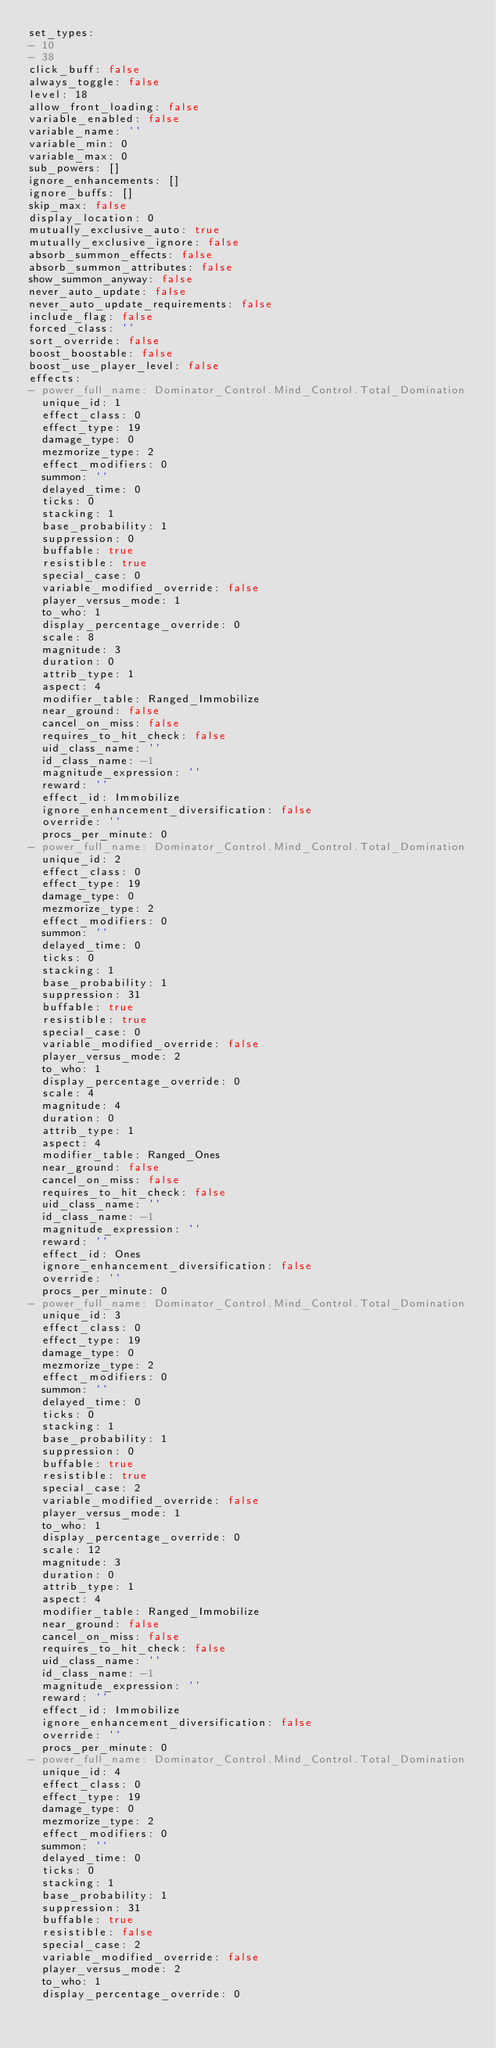Convert code to text. <code><loc_0><loc_0><loc_500><loc_500><_YAML_>set_types:
- 10
- 38
click_buff: false
always_toggle: false
level: 18
allow_front_loading: false
variable_enabled: false
variable_name: ''
variable_min: 0
variable_max: 0
sub_powers: []
ignore_enhancements: []
ignore_buffs: []
skip_max: false
display_location: 0
mutually_exclusive_auto: true
mutually_exclusive_ignore: false
absorb_summon_effects: false
absorb_summon_attributes: false
show_summon_anyway: false
never_auto_update: false
never_auto_update_requirements: false
include_flag: false
forced_class: ''
sort_override: false
boost_boostable: false
boost_use_player_level: false
effects:
- power_full_name: Dominator_Control.Mind_Control.Total_Domination
  unique_id: 1
  effect_class: 0
  effect_type: 19
  damage_type: 0
  mezmorize_type: 2
  effect_modifiers: 0
  summon: ''
  delayed_time: 0
  ticks: 0
  stacking: 1
  base_probability: 1
  suppression: 0
  buffable: true
  resistible: true
  special_case: 0
  variable_modified_override: false
  player_versus_mode: 1
  to_who: 1
  display_percentage_override: 0
  scale: 8
  magnitude: 3
  duration: 0
  attrib_type: 1
  aspect: 4
  modifier_table: Ranged_Immobilize
  near_ground: false
  cancel_on_miss: false
  requires_to_hit_check: false
  uid_class_name: ''
  id_class_name: -1
  magnitude_expression: ''
  reward: ''
  effect_id: Immobilize
  ignore_enhancement_diversification: false
  override: ''
  procs_per_minute: 0
- power_full_name: Dominator_Control.Mind_Control.Total_Domination
  unique_id: 2
  effect_class: 0
  effect_type: 19
  damage_type: 0
  mezmorize_type: 2
  effect_modifiers: 0
  summon: ''
  delayed_time: 0
  ticks: 0
  stacking: 1
  base_probability: 1
  suppression: 31
  buffable: true
  resistible: true
  special_case: 0
  variable_modified_override: false
  player_versus_mode: 2
  to_who: 1
  display_percentage_override: 0
  scale: 4
  magnitude: 4
  duration: 0
  attrib_type: 1
  aspect: 4
  modifier_table: Ranged_Ones
  near_ground: false
  cancel_on_miss: false
  requires_to_hit_check: false
  uid_class_name: ''
  id_class_name: -1
  magnitude_expression: ''
  reward: ''
  effect_id: Ones
  ignore_enhancement_diversification: false
  override: ''
  procs_per_minute: 0
- power_full_name: Dominator_Control.Mind_Control.Total_Domination
  unique_id: 3
  effect_class: 0
  effect_type: 19
  damage_type: 0
  mezmorize_type: 2
  effect_modifiers: 0
  summon: ''
  delayed_time: 0
  ticks: 0
  stacking: 1
  base_probability: 1
  suppression: 0
  buffable: true
  resistible: true
  special_case: 2
  variable_modified_override: false
  player_versus_mode: 1
  to_who: 1
  display_percentage_override: 0
  scale: 12
  magnitude: 3
  duration: 0
  attrib_type: 1
  aspect: 4
  modifier_table: Ranged_Immobilize
  near_ground: false
  cancel_on_miss: false
  requires_to_hit_check: false
  uid_class_name: ''
  id_class_name: -1
  magnitude_expression: ''
  reward: ''
  effect_id: Immobilize
  ignore_enhancement_diversification: false
  override: ''
  procs_per_minute: 0
- power_full_name: Dominator_Control.Mind_Control.Total_Domination
  unique_id: 4
  effect_class: 0
  effect_type: 19
  damage_type: 0
  mezmorize_type: 2
  effect_modifiers: 0
  summon: ''
  delayed_time: 0
  ticks: 0
  stacking: 1
  base_probability: 1
  suppression: 31
  buffable: true
  resistible: false
  special_case: 2
  variable_modified_override: false
  player_versus_mode: 2
  to_who: 1
  display_percentage_override: 0</code> 